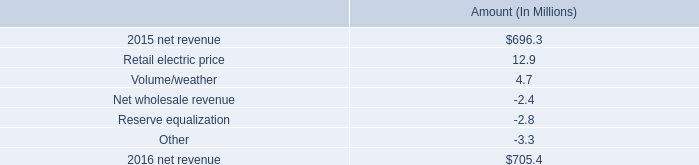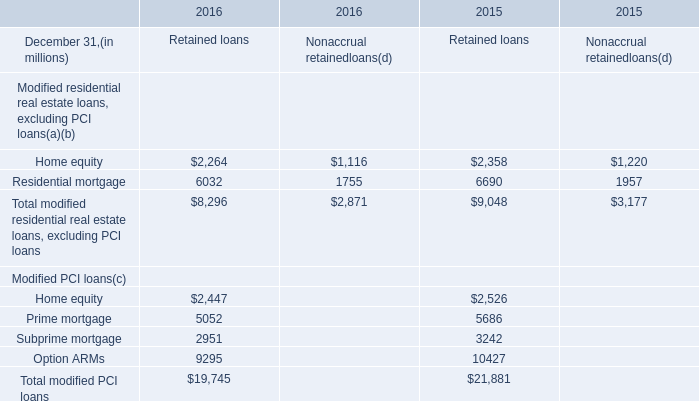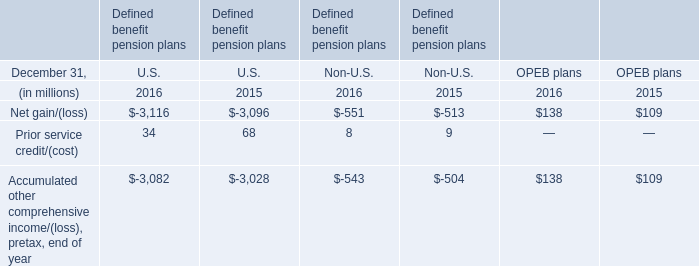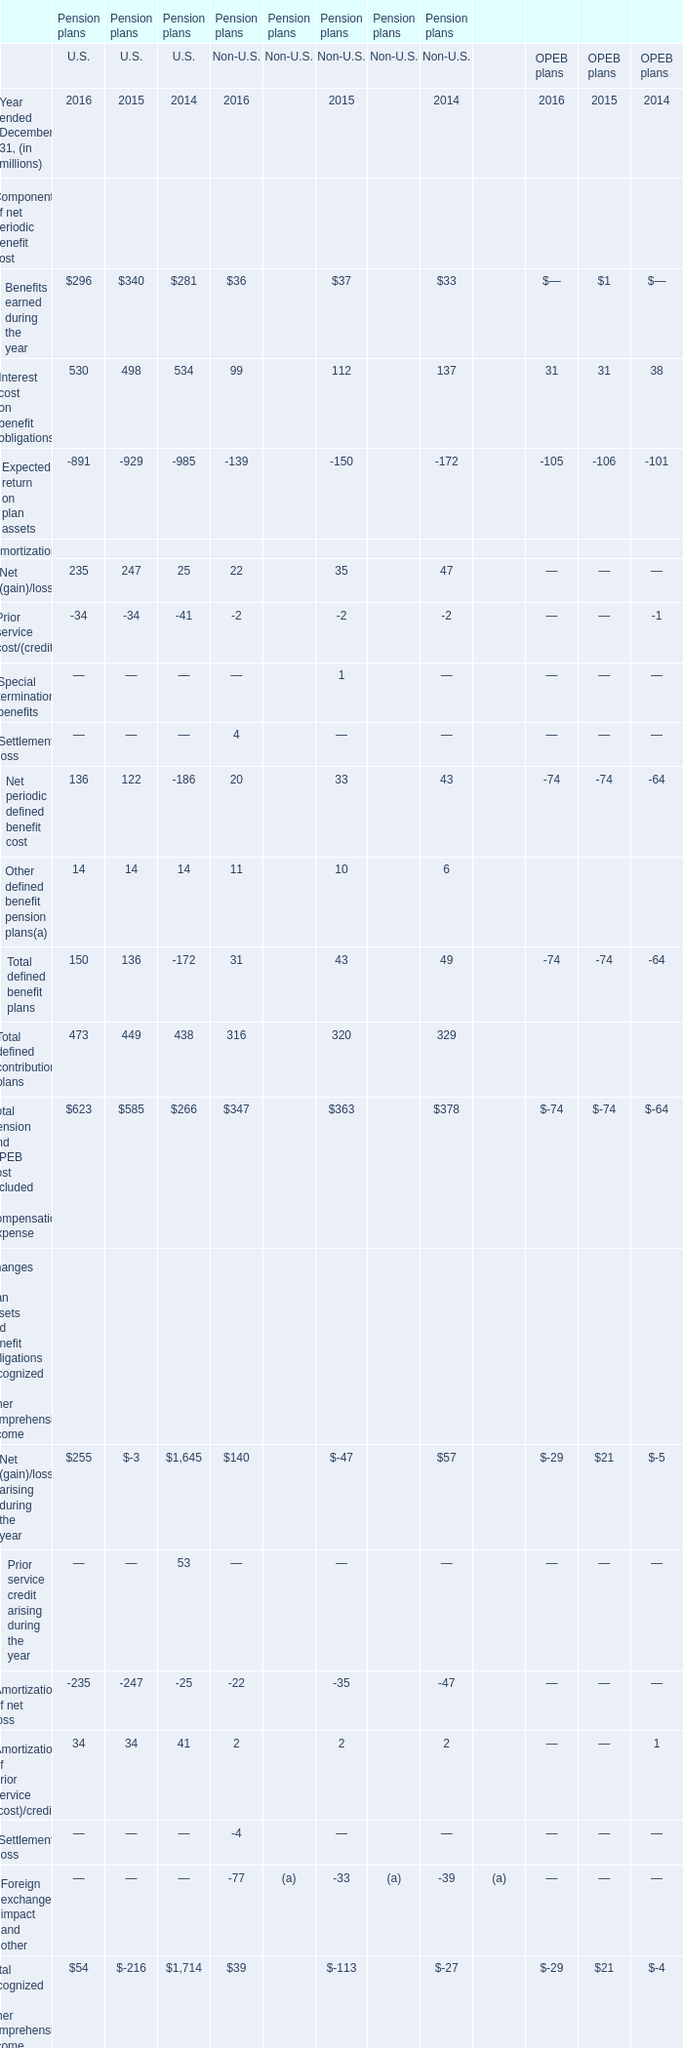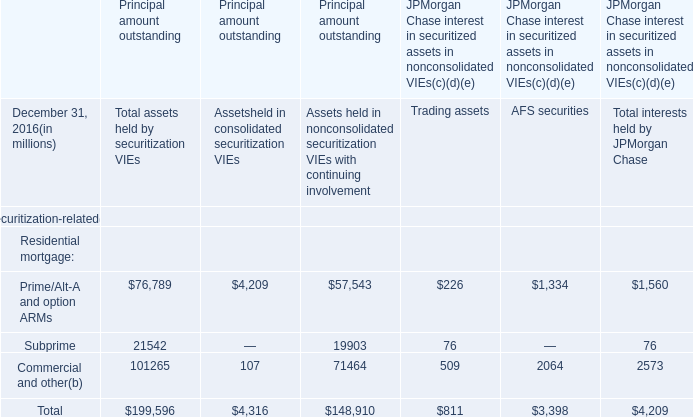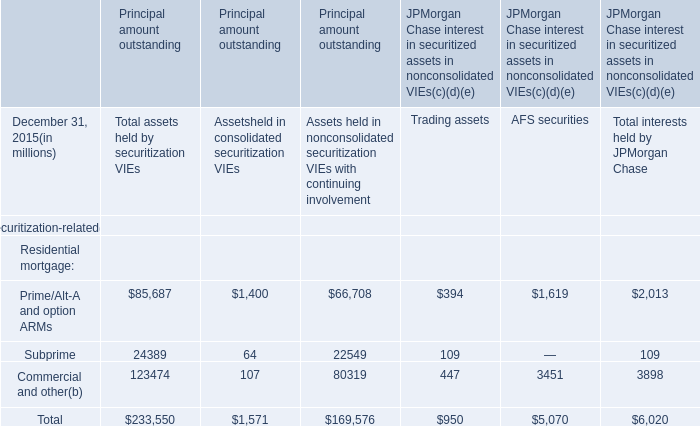What is the percentage of all Defined benefit pension that are positive to the total amount, in 2016? 
Computations: ((34 + 68) / (((((34 + 68) - 3116) - 3096) - 3082) - 3028))
Answer: -0.00835. 